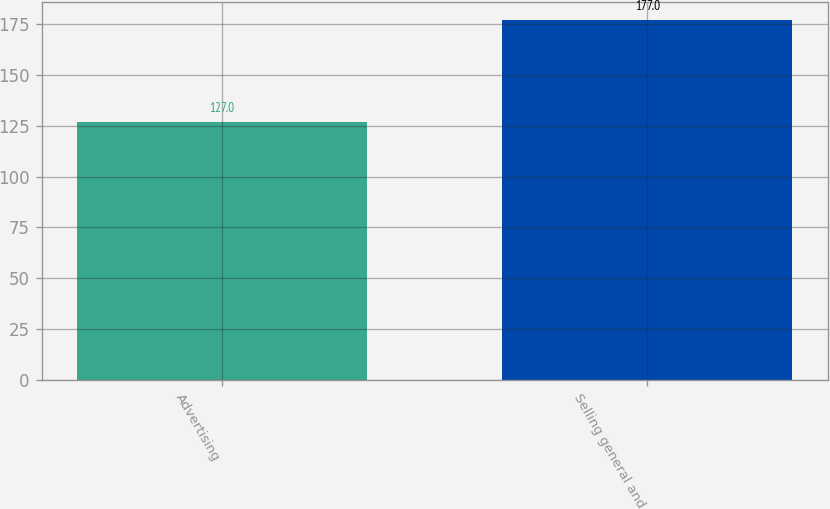Convert chart to OTSL. <chart><loc_0><loc_0><loc_500><loc_500><bar_chart><fcel>Advertising<fcel>Selling general and<nl><fcel>127<fcel>177<nl></chart> 